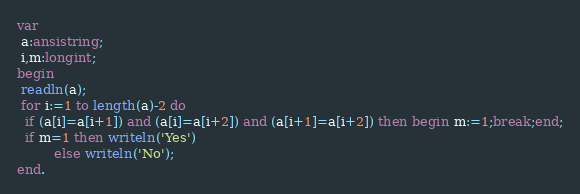Convert code to text. <code><loc_0><loc_0><loc_500><loc_500><_Pascal_>var
 a:ansistring;
 i,m:longint;
begin
 readln(a);
 for i:=1 to length(a)-2 do
  if (a[i]=a[i+1]) and (a[i]=a[i+2]) and (a[i+1]=a[i+2]) then begin m:=1;break;end;
  if m=1 then writeln('Yes')
         else writeln('No');
end.</code> 